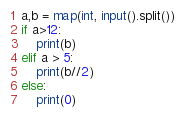<code> <loc_0><loc_0><loc_500><loc_500><_Python_>a,b = map(int, input().split())
if a>12:
    print(b)
elif a > 5:
    print(b//2)
else:
    print(0)</code> 